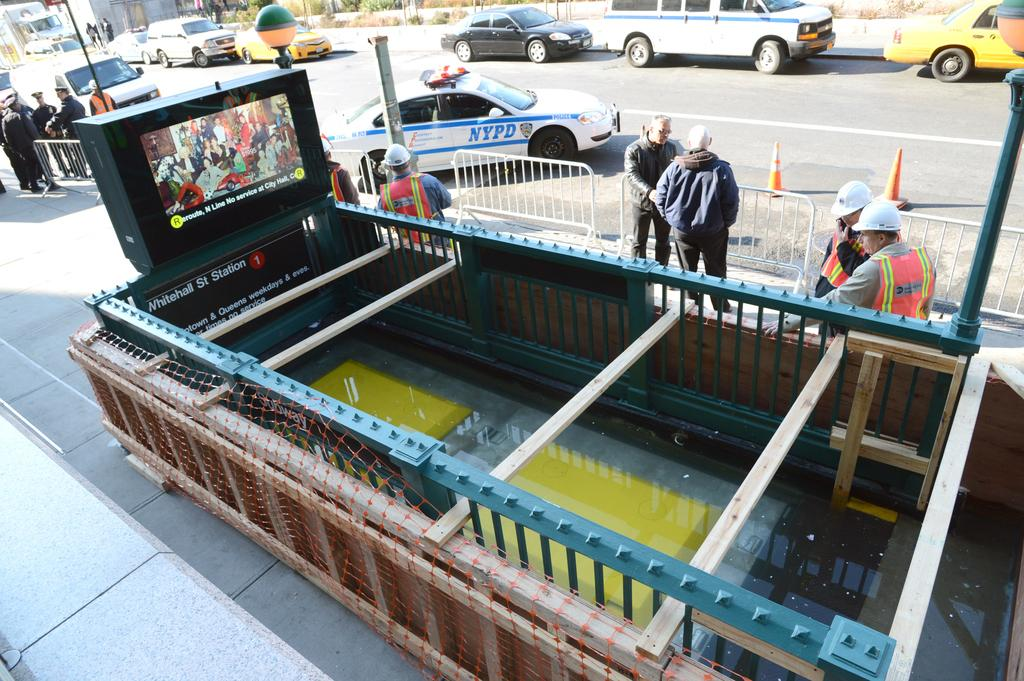<image>
Render a clear and concise summary of the photo. a group of contraction workers in front of the Whitehall St. Station. 